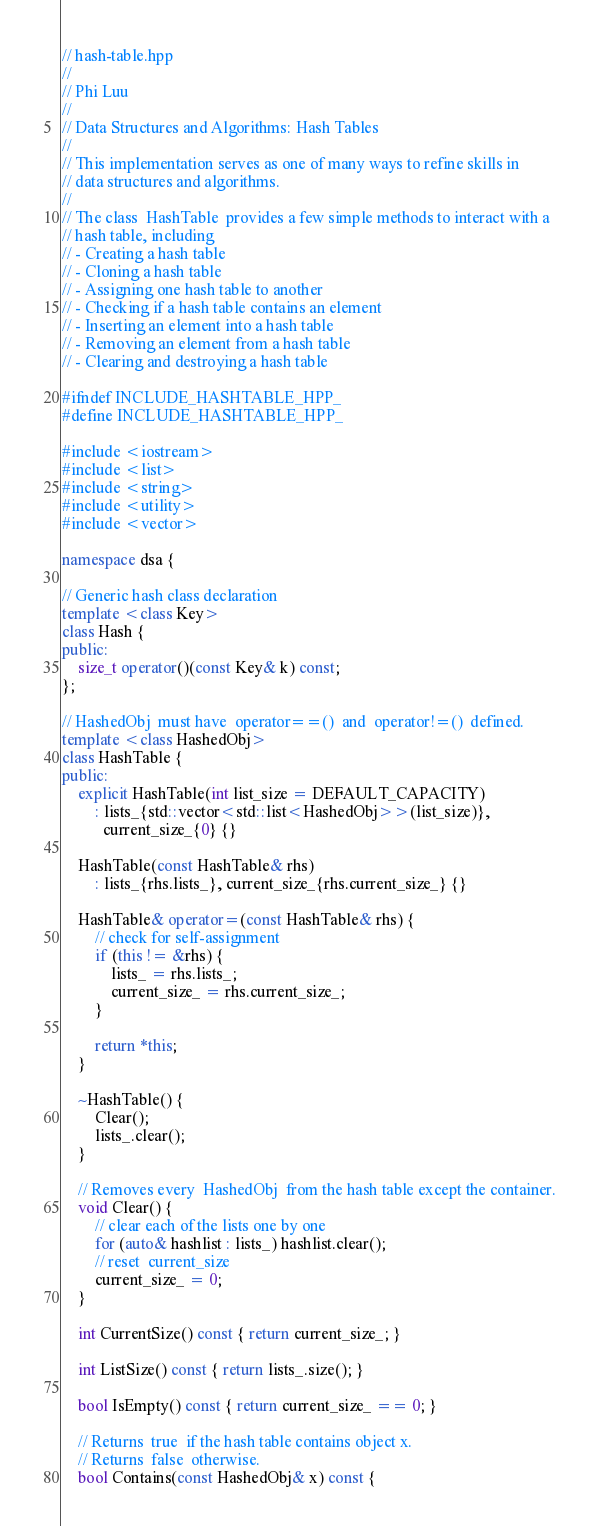<code> <loc_0><loc_0><loc_500><loc_500><_C++_>// hash-table.hpp
//
// Phi Luu
//
// Data Structures and Algorithms: Hash Tables
//
// This implementation serves as one of many ways to refine skills in
// data structures and algorithms.
//
// The class  HashTable  provides a few simple methods to interact with a
// hash table, including
// - Creating a hash table
// - Cloning a hash table
// - Assigning one hash table to another
// - Checking if a hash table contains an element
// - Inserting an element into a hash table
// - Removing an element from a hash table
// - Clearing and destroying a hash table

#ifndef INCLUDE_HASHTABLE_HPP_
#define INCLUDE_HASHTABLE_HPP_

#include <iostream>
#include <list>
#include <string>
#include <utility>
#include <vector>

namespace dsa {

// Generic hash class declaration
template <class Key>
class Hash {
public:
    size_t operator()(const Key& k) const;
};

// HashedObj  must have  operator==()  and  operator!=()  defined.
template <class HashedObj>
class HashTable {
public:
    explicit HashTable(int list_size = DEFAULT_CAPACITY)
        : lists_{std::vector<std::list<HashedObj>>(list_size)},
          current_size_{0} {}

    HashTable(const HashTable& rhs)
        : lists_{rhs.lists_}, current_size_{rhs.current_size_} {}

    HashTable& operator=(const HashTable& rhs) {
        // check for self-assignment
        if (this != &rhs) {
            lists_ = rhs.lists_;
            current_size_ = rhs.current_size_;
        }

        return *this;
    }

    ~HashTable() {
        Clear();
        lists_.clear();
    }

    // Removes every  HashedObj  from the hash table except the container.
    void Clear() {
        // clear each of the lists one by one
        for (auto& hashlist : lists_) hashlist.clear();
        // reset  current_size
        current_size_ = 0;
    }

    int CurrentSize() const { return current_size_; }

    int ListSize() const { return lists_.size(); }

    bool IsEmpty() const { return current_size_ == 0; }

    // Returns  true  if the hash table contains object x.
    // Returns  false  otherwise.
    bool Contains(const HashedObj& x) const {</code> 